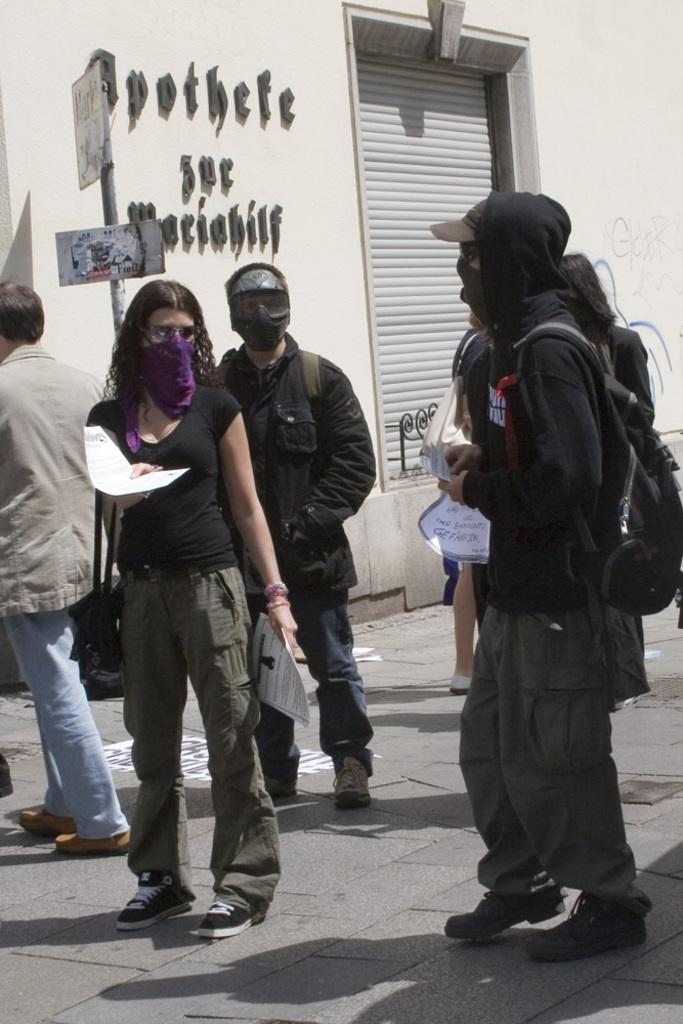How many people are in the image? There is a group of people standing in the image. What are two of the people holding? Two persons are holding papers. What can be seen attached to a pole in the image? There are boards attached to a pole. What is a feature of the building in the image? There is a shutter in the image. What can be read on the wall in the image? There are words visible on a wall. What type of cherry is being used as a decoration on the umbrella in the image? There is no cherry or umbrella present in the image. What type of canvas is being used to create the words on the wall in the image? The words on the wall are not described as being created on a canvas; they are simply visible on the wall. 